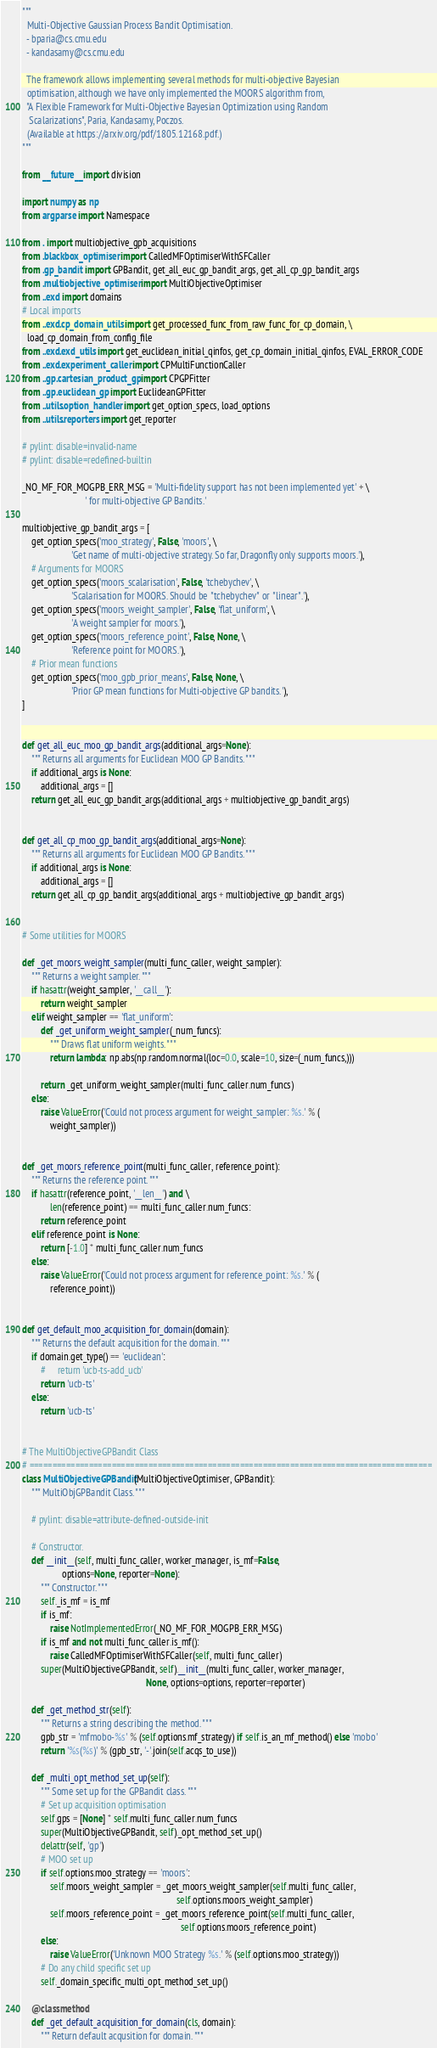Convert code to text. <code><loc_0><loc_0><loc_500><loc_500><_Python_>"""
  Multi-Objective Gaussian Process Bandit Optimisation.
  - bparia@cs.cmu.edu
  - kandasamy@cs.cmu.edu

  The framework allows implementing several methods for multi-objective Bayesian
  optimisation, although we have only implemented the MOORS algorithm from,
  "A Flexible Framework for Multi-Objective Bayesian Optimization using Random
   Scalarizations", Paria, Kandasamy, Poczos.
  (Available at https://arxiv.org/pdf/1805.12168.pdf.)
"""

from __future__ import division

import numpy as np
from argparse import Namespace

from . import multiobjective_gpb_acquisitions
from .blackbox_optimiser import CalledMFOptimiserWithSFCaller
from .gp_bandit import GPBandit, get_all_euc_gp_bandit_args, get_all_cp_gp_bandit_args
from .multiobjective_optimiser import MultiObjectiveOptimiser
from ..exd import domains
# Local imports
from ..exd.cp_domain_utils import get_processed_func_from_raw_func_for_cp_domain, \
  load_cp_domain_from_config_file
from ..exd.exd_utils import get_euclidean_initial_qinfos, get_cp_domain_initial_qinfos, EVAL_ERROR_CODE
from ..exd.experiment_caller import CPMultiFunctionCaller
from ..gp.cartesian_product_gp import CPGPFitter
from ..gp.euclidean_gp import EuclideanGPFitter
from ..utils.option_handler import get_option_specs, load_options
from ..utils.reporters import get_reporter

# pylint: disable=invalid-name
# pylint: disable=redefined-builtin

_NO_MF_FOR_MOGPB_ERR_MSG = 'Multi-fidelity support has not been implemented yet' + \
                           ' for multi-objective GP Bandits.'

multiobjective_gp_bandit_args = [
    get_option_specs('moo_strategy', False, 'moors', \
                     'Get name of multi-objective strategy. So far, Dragonfly only supports moors.'),
    # Arguments for MOORS
    get_option_specs('moors_scalarisation', False, 'tchebychev', \
                     'Scalarisation for MOORS. Should be "tchebychev" or "linear".'),
    get_option_specs('moors_weight_sampler', False, 'flat_uniform', \
                     'A weight sampler for moors.'),
    get_option_specs('moors_reference_point', False, None, \
                     'Reference point for MOORS.'),
    # Prior mean functions
    get_option_specs('moo_gpb_prior_means', False, None, \
                     'Prior GP mean functions for Multi-objective GP bandits.'),
]


def get_all_euc_moo_gp_bandit_args(additional_args=None):
    """ Returns all arguments for Euclidean MOO GP Bandits. """
    if additional_args is None:
        additional_args = []
    return get_all_euc_gp_bandit_args(additional_args + multiobjective_gp_bandit_args)


def get_all_cp_moo_gp_bandit_args(additional_args=None):
    """ Returns all arguments for Euclidean MOO GP Bandits. """
    if additional_args is None:
        additional_args = []
    return get_all_cp_gp_bandit_args(additional_args + multiobjective_gp_bandit_args)


# Some utilities for MOORS

def _get_moors_weight_sampler(multi_func_caller, weight_sampler):
    """ Returns a weight sampler. """
    if hasattr(weight_sampler, '__call__'):
        return weight_sampler
    elif weight_sampler == 'flat_uniform':
        def _get_uniform_weight_sampler(_num_funcs):
            """ Draws flat uniform weights. """
            return lambda: np.abs(np.random.normal(loc=0.0, scale=10, size=(_num_funcs,)))

        return _get_uniform_weight_sampler(multi_func_caller.num_funcs)
    else:
        raise ValueError('Could not process argument for weight_sampler: %s.' % (
            weight_sampler))


def _get_moors_reference_point(multi_func_caller, reference_point):
    """ Returns the reference point. """
    if hasattr(reference_point, '__len__') and \
            len(reference_point) == multi_func_caller.num_funcs:
        return reference_point
    elif reference_point is None:
        return [-1.0] * multi_func_caller.num_funcs
    else:
        raise ValueError('Could not process argument for reference_point: %s.' % (
            reference_point))


def get_default_moo_acquisition_for_domain(domain):
    """ Returns the default acquisition for the domain. """
    if domain.get_type() == 'euclidean':
        #     return 'ucb-ts-add_ucb'
        return 'ucb-ts'
    else:
        return 'ucb-ts'


# The MultiObjectiveGPBandit Class
# ========================================================================================
class MultiObjectiveGPBandit(MultiObjectiveOptimiser, GPBandit):
    """ MultiObjGPBandit Class. """

    # pylint: disable=attribute-defined-outside-init

    # Constructor.
    def __init__(self, multi_func_caller, worker_manager, is_mf=False,
                 options=None, reporter=None):
        """ Constructor. """
        self._is_mf = is_mf
        if is_mf:
            raise NotImplementedError(_NO_MF_FOR_MOGPB_ERR_MSG)
        if is_mf and not multi_func_caller.is_mf():
            raise CalledMFOptimiserWithSFCaller(self, multi_func_caller)
        super(MultiObjectiveGPBandit, self).__init__(multi_func_caller, worker_manager,
                                                     None, options=options, reporter=reporter)

    def _get_method_str(self):
        """ Returns a string describing the method. """
        gpb_str = 'mfmobo-%s' % (self.options.mf_strategy) if self.is_an_mf_method() else 'mobo'
        return '%s(%s)' % (gpb_str, '-'.join(self.acqs_to_use))

    def _multi_opt_method_set_up(self):
        """ Some set up for the GPBandit class. """
        # Set up acquisition optimisation
        self.gps = [None] * self.multi_func_caller.num_funcs
        super(MultiObjectiveGPBandit, self)._opt_method_set_up()
        delattr(self, 'gp')
        # MOO set up
        if self.options.moo_strategy == 'moors':
            self.moors_weight_sampler = _get_moors_weight_sampler(self.multi_func_caller,
                                                                  self.options.moors_weight_sampler)
            self.moors_reference_point = _get_moors_reference_point(self.multi_func_caller,
                                                                    self.options.moors_reference_point)
        else:
            raise ValueError('Unknown MOO Strategy %s.' % (self.options.moo_strategy))
        # Do any child specific set up
        self._domain_specific_multi_opt_method_set_up()

    @classmethod
    def _get_default_acquisition_for_domain(cls, domain):
        """ Return default acqusition for domain. """</code> 